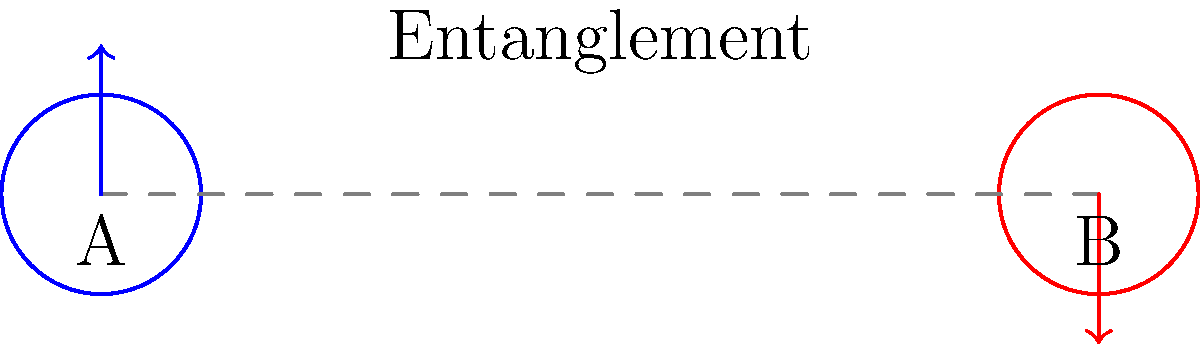In the diagram above, particles A and B are entangled quantum particles. If particle A is measured to have an up-spin, what can you conclude about the spin of particle B, and how does this demonstrate quantum entanglement? Explain how you would communicate this concept to a general audience. To explain quantum entanglement to a general audience:

1. Introduce the concept: Quantum entanglement is a phenomenon where two particles become interconnected, and the quantum state of each particle cannot be described independently.

2. Use the diagram: Point out that particles A and B are connected by a dashed line, representing their entanglement.

3. Explain spin: Describe spin as a quantum property, like a particle's intrinsic angular momentum. For simplicity, we often represent it as "up" or "down."

4. Measurement effect: When we measure particle A and find it has an up-spin (shown by the upward arrow), particle B instantaneously adopts the opposite spin (downward arrow).

5. Non-classical behavior: Emphasize that this occurs faster than light could travel between the particles, which is not possible in classical physics.

6. Probabilistic nature: Before measurement, both particles exist in a superposition of states. The act of measuring one particle determines the state of both.

7. Einstein's "spooky action at a distance": Mention this famous quote to illustrate how counterintuitive this phenomenon is.

8. Real-world applications: Briefly mention applications like quantum computing or secure communication to show relevance.

9. Analogy: Compare it to a pair of gloves. If you randomly select one and find it's left-handed, you instantly know the other is right-handed, regardless of distance.

Key point: Stress that entanglement demonstrates the interconnectedness of particles in quantum systems, challenging our classical intuitions about reality and causality.
Answer: Particle B will have down-spin, demonstrating the instantaneous correlation of entangled particles' states regardless of distance. 